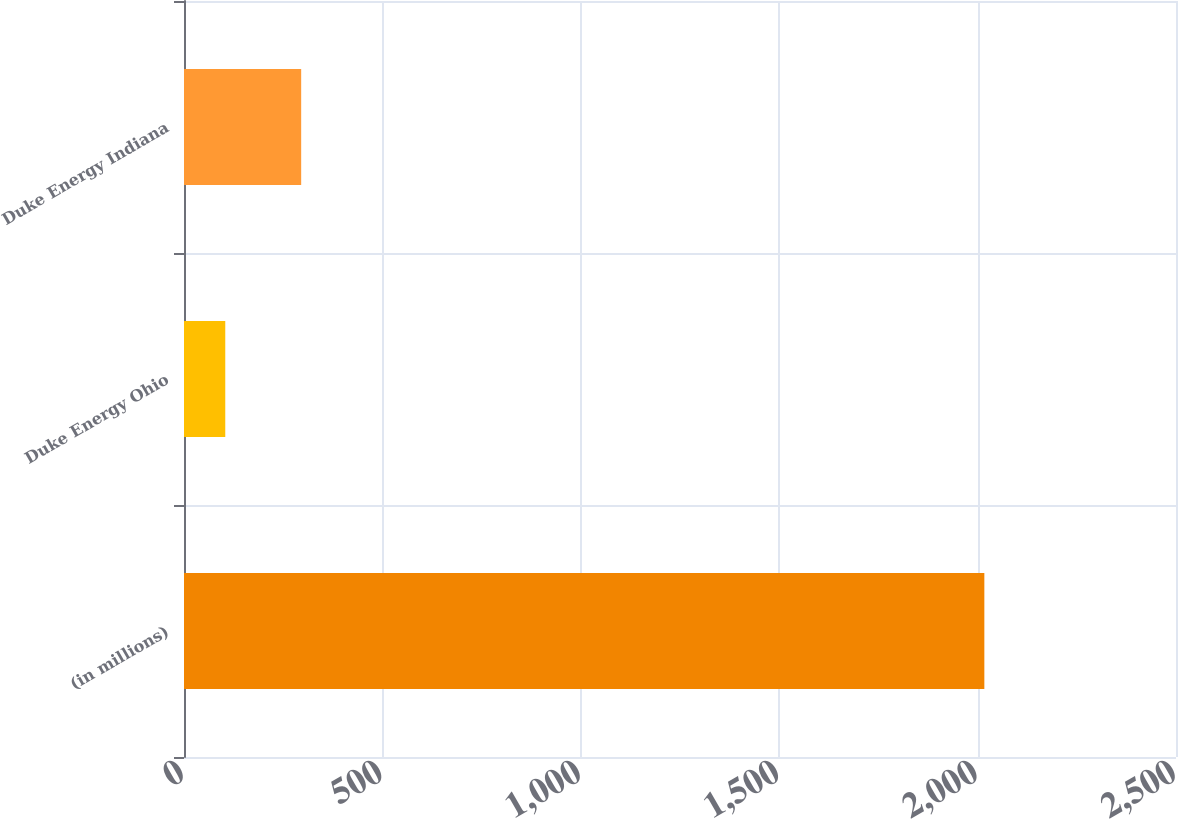Convert chart to OTSL. <chart><loc_0><loc_0><loc_500><loc_500><bar_chart><fcel>(in millions)<fcel>Duke Energy Ohio<fcel>Duke Energy Indiana<nl><fcel>2017<fcel>104<fcel>295.3<nl></chart> 